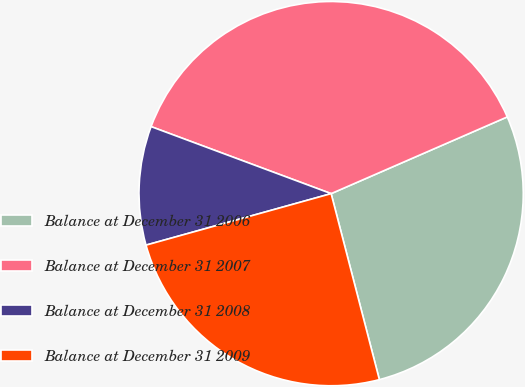Convert chart to OTSL. <chart><loc_0><loc_0><loc_500><loc_500><pie_chart><fcel>Balance at December 31 2006<fcel>Balance at December 31 2007<fcel>Balance at December 31 2008<fcel>Balance at December 31 2009<nl><fcel>27.5%<fcel>37.79%<fcel>9.99%<fcel>24.72%<nl></chart> 